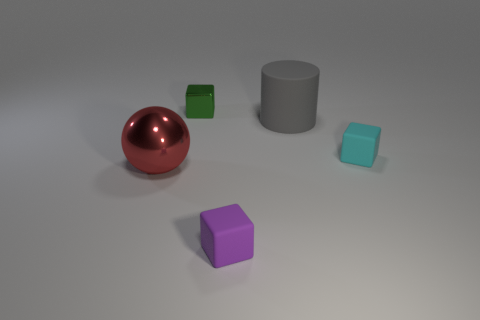Is the metal sphere the same color as the big cylinder?
Keep it short and to the point. No. How many small green shiny cubes are right of the small cube in front of the small cyan block that is to the right of the small metal object?
Provide a short and direct response. 0. How big is the green metal cube?
Offer a very short reply. Small. What material is the cylinder that is the same size as the ball?
Make the answer very short. Rubber. There is a gray cylinder; how many tiny blocks are right of it?
Keep it short and to the point. 1. Is the material of the small cube behind the gray cylinder the same as the small thing right of the small purple rubber block?
Your answer should be very brief. No. There is a metallic thing that is in front of the matte cube that is behind the metallic thing in front of the metallic block; what shape is it?
Offer a terse response. Sphere. The small green shiny thing has what shape?
Keep it short and to the point. Cube. The purple thing that is the same size as the shiny cube is what shape?
Your answer should be very brief. Cube. How many other things are there of the same color as the small shiny thing?
Give a very brief answer. 0. 